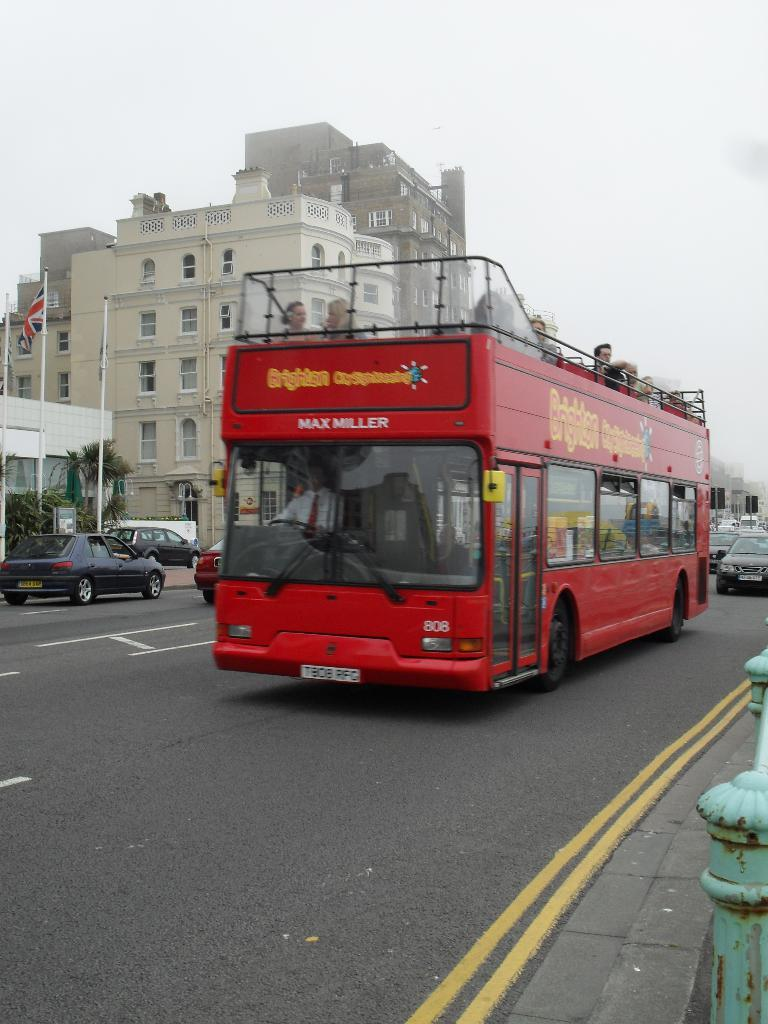What is happening in the image? There are vehicles moving on a road in the image. What can be seen in the distance in the image? There are buildings, trees, flagpoles, and the sky visible in the background of the image. Can you describe the bottom right of the image? There is a railing on the bottom right of the image. What type of veil is draped over the vehicles in the image? There is no veil present in the image; the vehicles are not covered or draped in any way. Can you read any writing on the vehicles in the image? There is no writing visible on the vehicles in the image. 